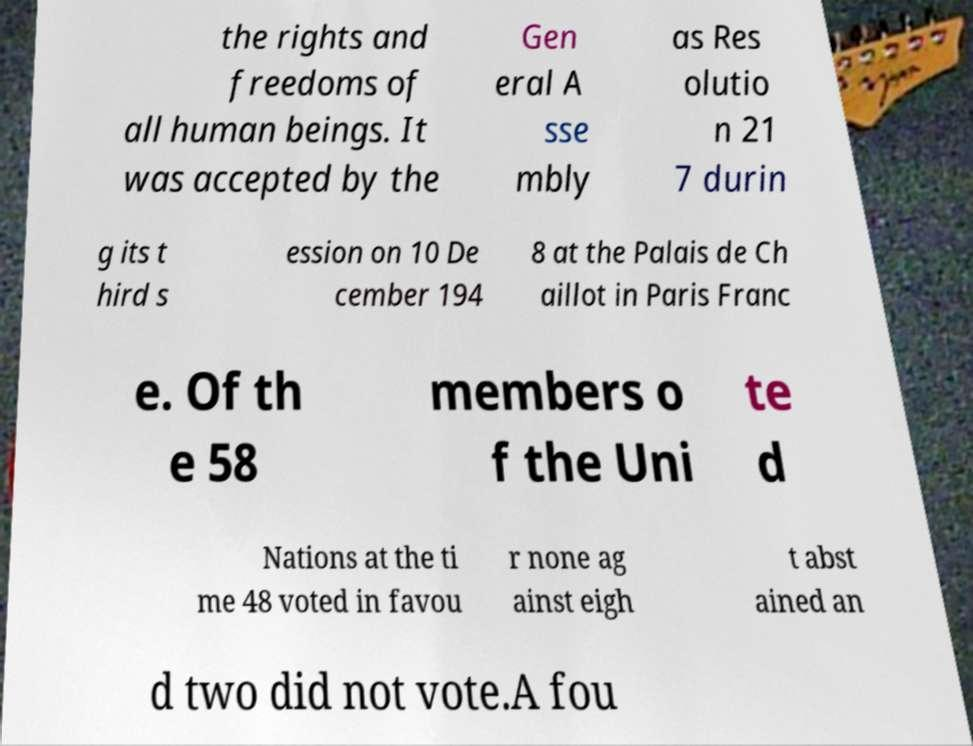Please identify and transcribe the text found in this image. the rights and freedoms of all human beings. It was accepted by the Gen eral A sse mbly as Res olutio n 21 7 durin g its t hird s ession on 10 De cember 194 8 at the Palais de Ch aillot in Paris Franc e. Of th e 58 members o f the Uni te d Nations at the ti me 48 voted in favou r none ag ainst eigh t abst ained an d two did not vote.A fou 